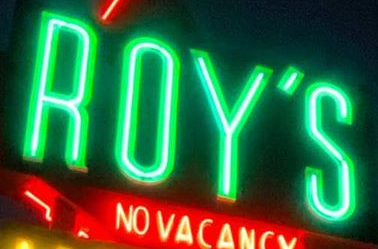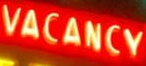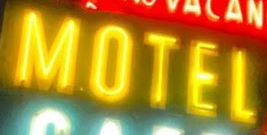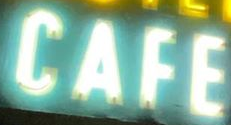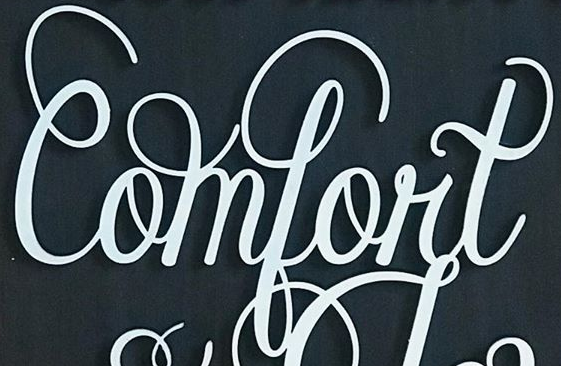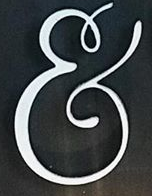What text appears in these images from left to right, separated by a semicolon? ROY'S; VACANCY; MOTEL; CAFE; Comfort; & 